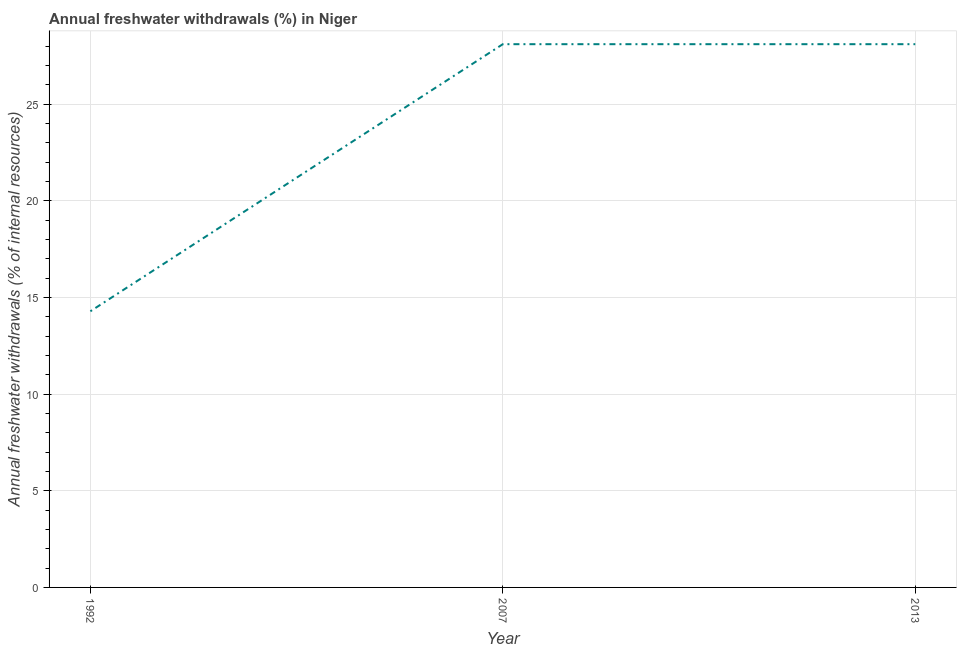What is the annual freshwater withdrawals in 2007?
Give a very brief answer. 28.1. Across all years, what is the maximum annual freshwater withdrawals?
Keep it short and to the point. 28.1. Across all years, what is the minimum annual freshwater withdrawals?
Ensure brevity in your answer.  14.29. In which year was the annual freshwater withdrawals maximum?
Provide a short and direct response. 2007. What is the sum of the annual freshwater withdrawals?
Your answer should be compact. 70.49. What is the difference between the annual freshwater withdrawals in 1992 and 2013?
Offer a terse response. -13.82. What is the average annual freshwater withdrawals per year?
Offer a very short reply. 23.5. What is the median annual freshwater withdrawals?
Your answer should be compact. 28.1. Do a majority of the years between 2013 and 2007 (inclusive) have annual freshwater withdrawals greater than 15 %?
Offer a terse response. No. What is the ratio of the annual freshwater withdrawals in 1992 to that in 2007?
Give a very brief answer. 0.51. What is the difference between the highest and the second highest annual freshwater withdrawals?
Make the answer very short. 0. What is the difference between the highest and the lowest annual freshwater withdrawals?
Your answer should be very brief. 13.82. Does the annual freshwater withdrawals monotonically increase over the years?
Offer a very short reply. No. How many lines are there?
Keep it short and to the point. 1. How many years are there in the graph?
Provide a short and direct response. 3. What is the difference between two consecutive major ticks on the Y-axis?
Offer a terse response. 5. Are the values on the major ticks of Y-axis written in scientific E-notation?
Your answer should be compact. No. Does the graph contain any zero values?
Give a very brief answer. No. Does the graph contain grids?
Your answer should be very brief. Yes. What is the title of the graph?
Make the answer very short. Annual freshwater withdrawals (%) in Niger. What is the label or title of the Y-axis?
Give a very brief answer. Annual freshwater withdrawals (% of internal resources). What is the Annual freshwater withdrawals (% of internal resources) in 1992?
Give a very brief answer. 14.29. What is the Annual freshwater withdrawals (% of internal resources) of 2007?
Keep it short and to the point. 28.1. What is the Annual freshwater withdrawals (% of internal resources) in 2013?
Your response must be concise. 28.1. What is the difference between the Annual freshwater withdrawals (% of internal resources) in 1992 and 2007?
Keep it short and to the point. -13.82. What is the difference between the Annual freshwater withdrawals (% of internal resources) in 1992 and 2013?
Offer a very short reply. -13.82. What is the difference between the Annual freshwater withdrawals (% of internal resources) in 2007 and 2013?
Keep it short and to the point. 0. What is the ratio of the Annual freshwater withdrawals (% of internal resources) in 1992 to that in 2007?
Give a very brief answer. 0.51. What is the ratio of the Annual freshwater withdrawals (% of internal resources) in 1992 to that in 2013?
Your answer should be compact. 0.51. 